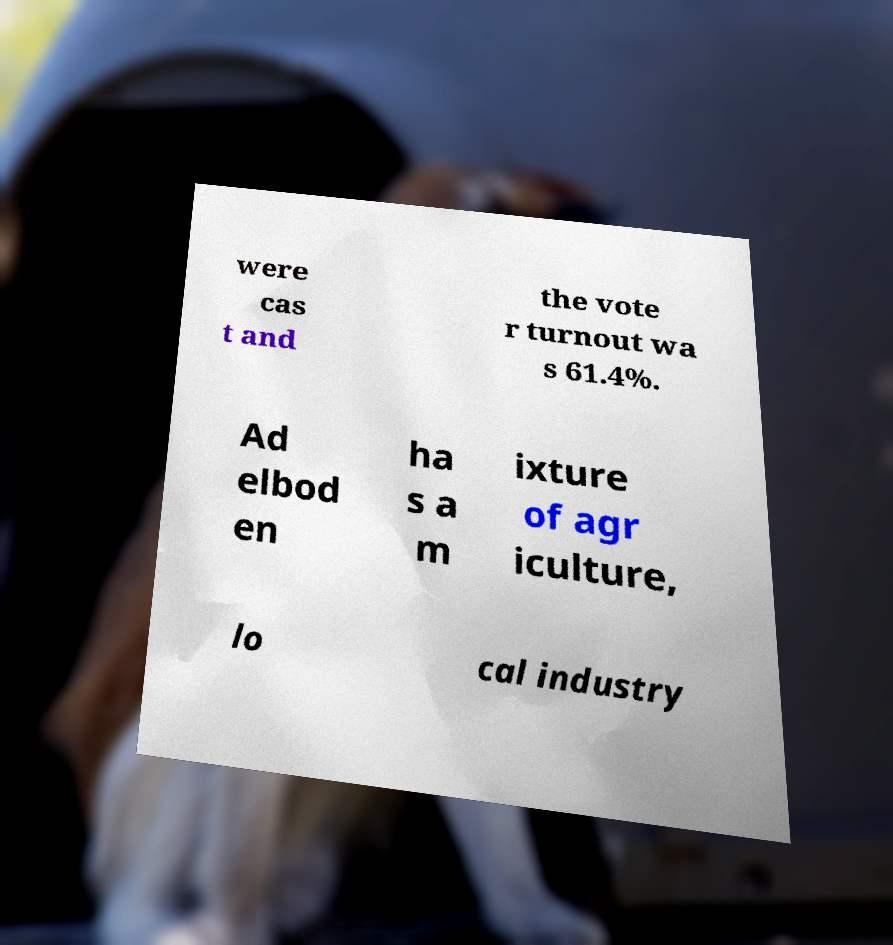What messages or text are displayed in this image? I need them in a readable, typed format. were cas t and the vote r turnout wa s 61.4%. Ad elbod en ha s a m ixture of agr iculture, lo cal industry 